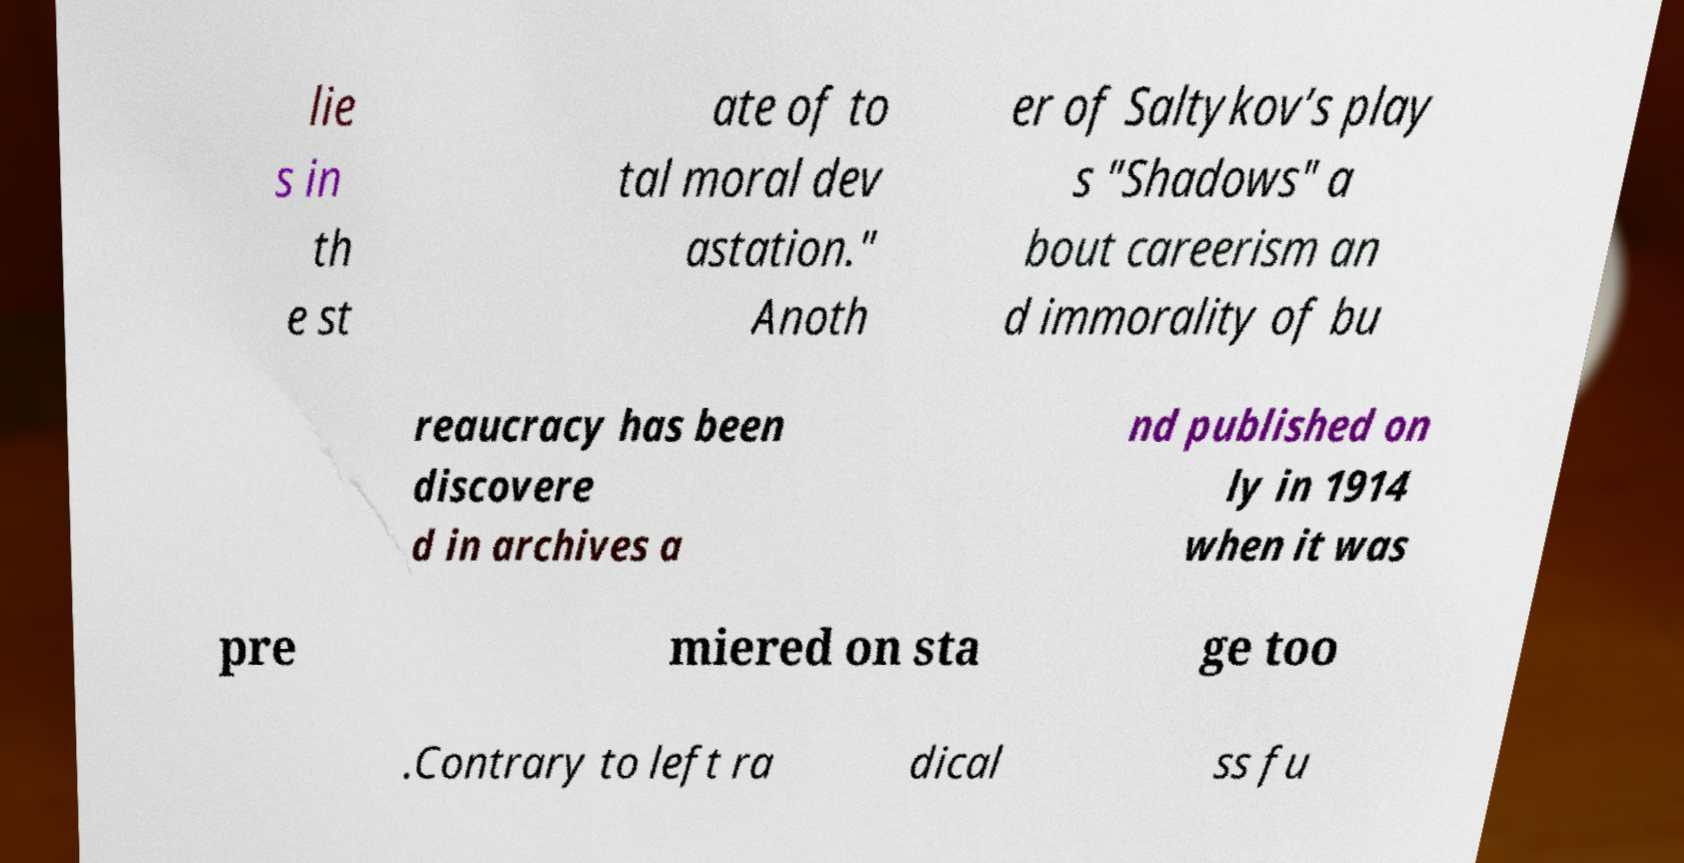There's text embedded in this image that I need extracted. Can you transcribe it verbatim? lie s in th e st ate of to tal moral dev astation." Anoth er of Saltykov’s play s "Shadows" a bout careerism an d immorality of bu reaucracy has been discovere d in archives a nd published on ly in 1914 when it was pre miered on sta ge too .Contrary to left ra dical ss fu 